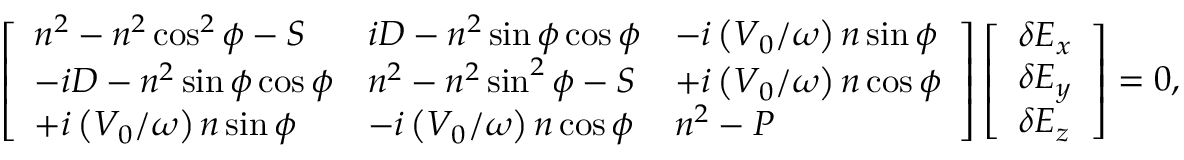<formula> <loc_0><loc_0><loc_500><loc_500>\left [ \begin{array} { l l l } { n ^ { 2 } - n ^ { 2 } \cos ^ { 2 } \phi - S } & { i D - n ^ { 2 } \sin \phi \cos \phi } & { - i \left ( V _ { 0 } / \omega \right ) n \sin \phi } \\ { - i D - n ^ { 2 } \sin \phi \cos \phi } & { n ^ { 2 } - n ^ { 2 } \sin ^ { 2 } \phi - S } & { + i \left ( V _ { 0 } / \omega \right ) n \cos \phi } \\ { + i \left ( V _ { 0 } / \omega \right ) n \sin \phi } & { - i \left ( V _ { 0 } / \omega \right ) n \cos \phi } & { n ^ { 2 } - P } \end{array} \right ] \left [ \begin{array} { l } { \delta E _ { x } } \\ { \delta E _ { y } } \\ { \delta E _ { z } } \end{array} \right ] = 0 ,</formula> 